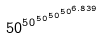Convert formula to latex. <formula><loc_0><loc_0><loc_500><loc_500>5 0 ^ { 5 0 ^ { 5 0 ^ { 5 0 ^ { 5 0 ^ { 6 . 8 3 9 } } } } }</formula> 